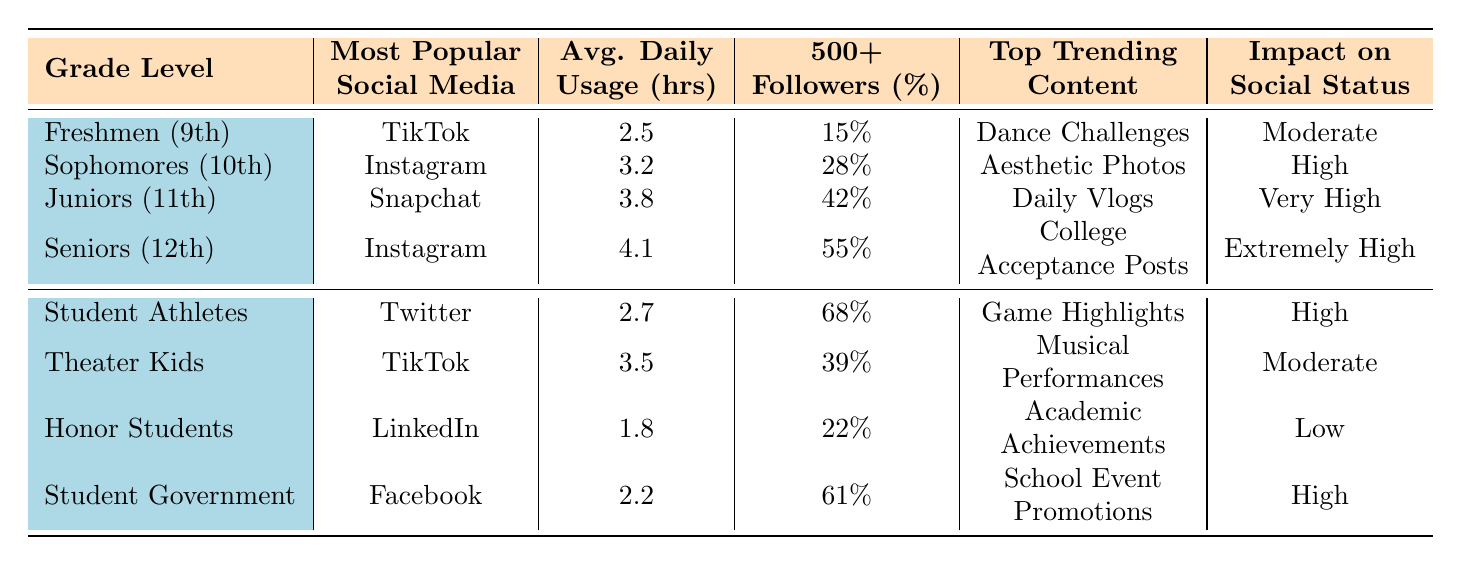What is the most popular social media platform among Seniors? According to the table, the most popular social media platform for Seniors is Instagram. This is listed directly under the "Most Popular Social Media Platform" column in the row for Seniors (12th Grade).
Answer: Instagram Which grade level has the highest average daily usage of social media? Looking at the "Average Daily Usage (hours)" column, Seniors have the highest average daily usage at 4.1 hours, followed by Juniors at 3.8 hours. Therefore, Seniors have the highest usage.
Answer: Seniors What percentage of Juniors have 500 or more followers? The percentage of Juniors with 500+ followers is listed in the table under the "Percentage with 500+ Followers" column, which shows 42% for Juniors.
Answer: 42% True or False: Student Athletes use social media for academic achievements? The table specifies that Student Athletes use Twitter, and their top trending content type is "Game Highlights". There is no mention of academic achievements in their row, so the statement is false.
Answer: False Calculate the average daily usage of social media for grade levels (Freshmen, Sophomores, and Juniors). To calculate the average, we take the average daily usage values for those groups: (2.5 + 3.2 + 3.8) = 9.5 hours. Then, we divide this total by the number of groups (3) to get the average: 9.5/3 = 3.17 hours.
Answer: 3.17 hours Which grade level has the lowest percentage of students with 500+ followers? Referring to the "Percentage with 500+ Followers" column, the lowest percentage is seen for Freshmen at 15%. Therefore, Freshmen have the lowest percentage of students with 500+ followers.
Answer: Freshmen How does the impact on social status compare between the different grade levels? In the table, the impact on social status increases from Moderate for Freshmen and Theater Kids to Extremely High for Seniors, indicating that as students progress through grades, their social media impact tends to increase.
Answer: It increases with grade levels Which social media platform is most popular among Student Government members? The table shows that Student Government members prefer Facebook as indicated in the "Most Popular Social Media Platform" column for that row.
Answer: Facebook What is the top trending content type for Honor Students? According to the table, Honor Students have "Academic Achievements" as their top trending content type. This is found under the "Top Trending Content Type" column for Honor Students.
Answer: Academic Achievements If combined, what would be the total percentage of students with 500+ followers among the Student Athletes and Seniors? The percentages for Student Athletes and Seniors are 68% and 55%, respectively. Adding them together gives 68% + 55% = 123%. Therefore, the total percentage of students with 500+ followers among these groups is 123%.
Answer: 123% 